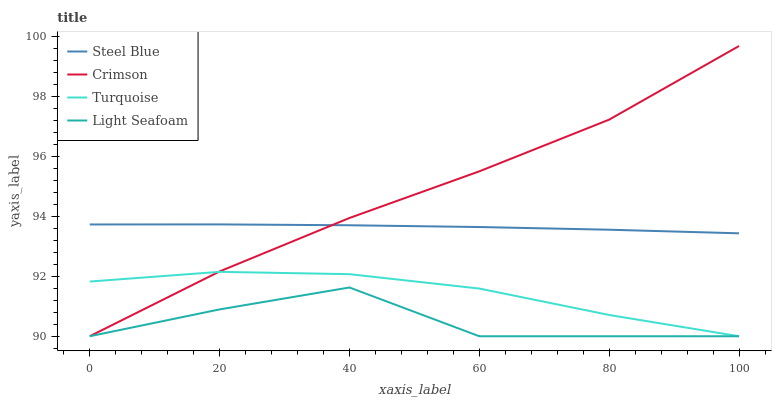Does Light Seafoam have the minimum area under the curve?
Answer yes or no. Yes. Does Crimson have the maximum area under the curve?
Answer yes or no. Yes. Does Turquoise have the minimum area under the curve?
Answer yes or no. No. Does Turquoise have the maximum area under the curve?
Answer yes or no. No. Is Steel Blue the smoothest?
Answer yes or no. Yes. Is Light Seafoam the roughest?
Answer yes or no. Yes. Is Turquoise the smoothest?
Answer yes or no. No. Is Turquoise the roughest?
Answer yes or no. No. Does Crimson have the lowest value?
Answer yes or no. Yes. Does Steel Blue have the lowest value?
Answer yes or no. No. Does Crimson have the highest value?
Answer yes or no. Yes. Does Turquoise have the highest value?
Answer yes or no. No. Is Light Seafoam less than Steel Blue?
Answer yes or no. Yes. Is Steel Blue greater than Light Seafoam?
Answer yes or no. Yes. Does Crimson intersect Steel Blue?
Answer yes or no. Yes. Is Crimson less than Steel Blue?
Answer yes or no. No. Is Crimson greater than Steel Blue?
Answer yes or no. No. Does Light Seafoam intersect Steel Blue?
Answer yes or no. No. 